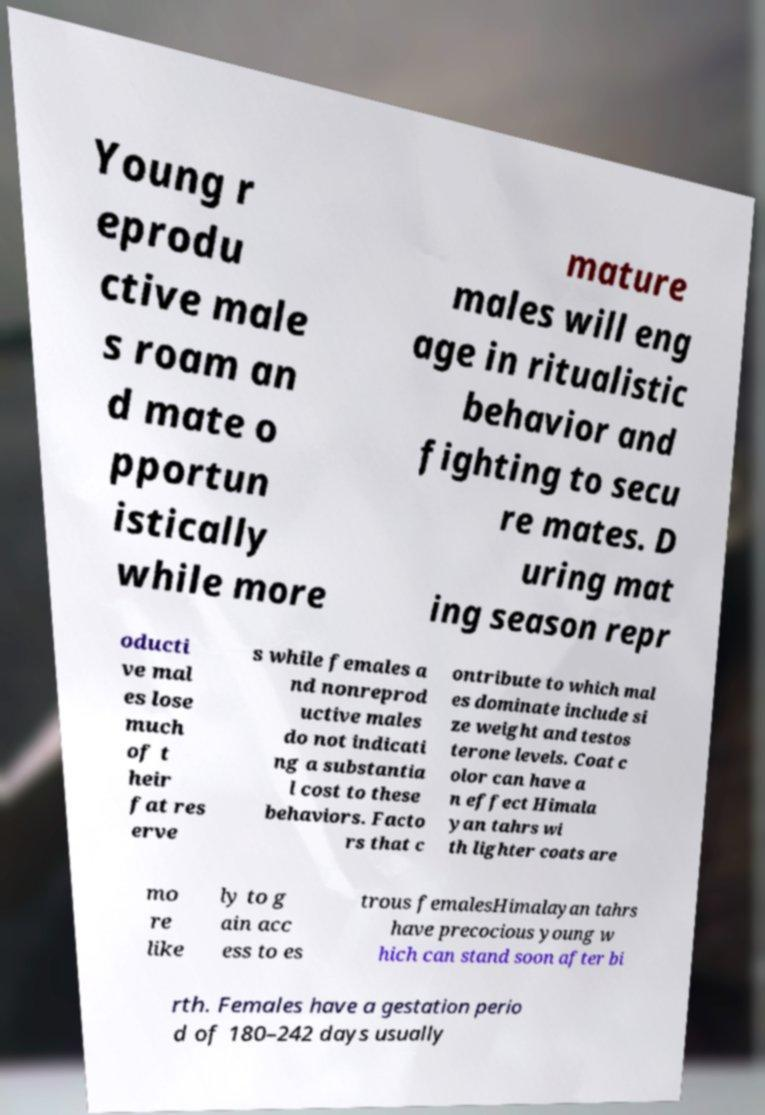What messages or text are displayed in this image? I need them in a readable, typed format. Young r eprodu ctive male s roam an d mate o pportun istically while more mature males will eng age in ritualistic behavior and fighting to secu re mates. D uring mat ing season repr oducti ve mal es lose much of t heir fat res erve s while females a nd nonreprod uctive males do not indicati ng a substantia l cost to these behaviors. Facto rs that c ontribute to which mal es dominate include si ze weight and testos terone levels. Coat c olor can have a n effect Himala yan tahrs wi th lighter coats are mo re like ly to g ain acc ess to es trous femalesHimalayan tahrs have precocious young w hich can stand soon after bi rth. Females have a gestation perio d of 180–242 days usually 